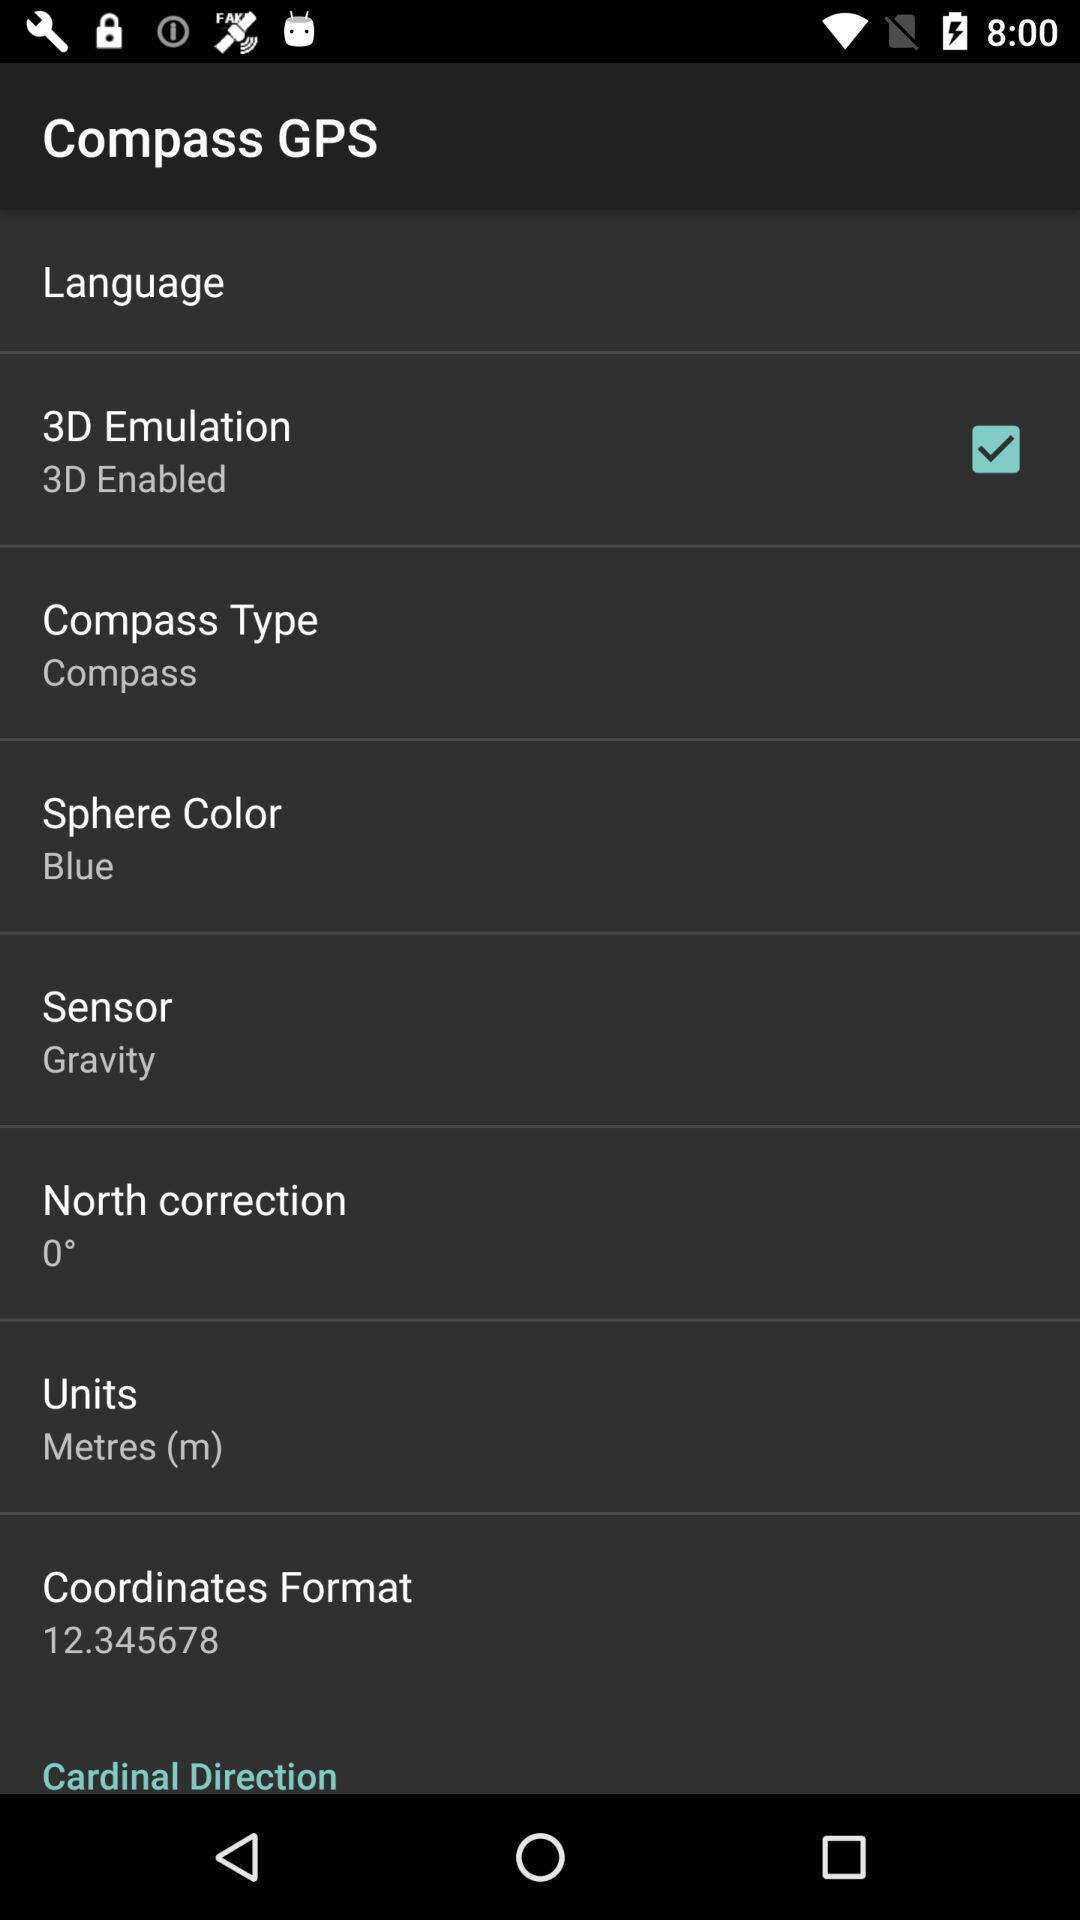What is the difference in altitude between the user's current location and sea level?
Answer the question using a single word or phrase. 207 m 